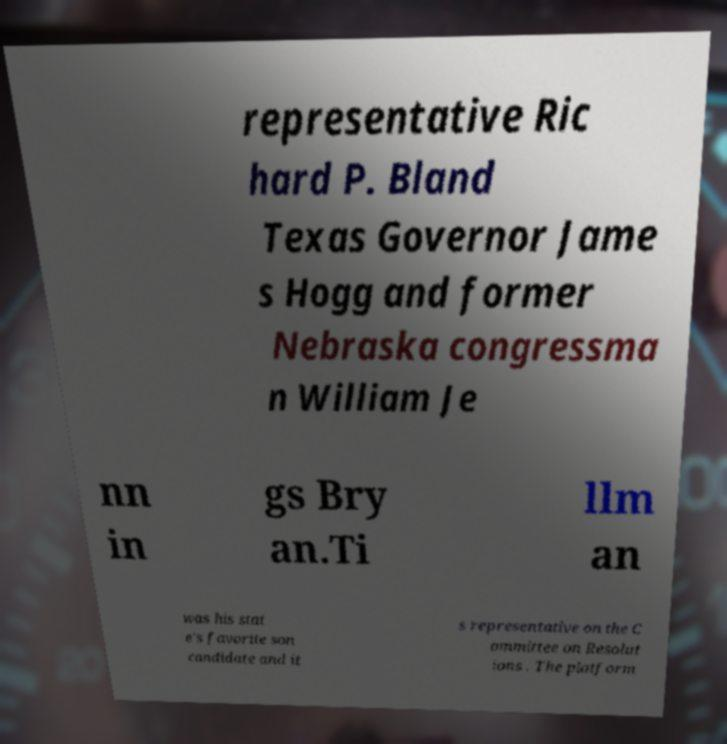Please read and relay the text visible in this image. What does it say? representative Ric hard P. Bland Texas Governor Jame s Hogg and former Nebraska congressma n William Je nn in gs Bry an.Ti llm an was his stat e's favorite son candidate and it s representative on the C ommittee on Resolut ions . The platform 